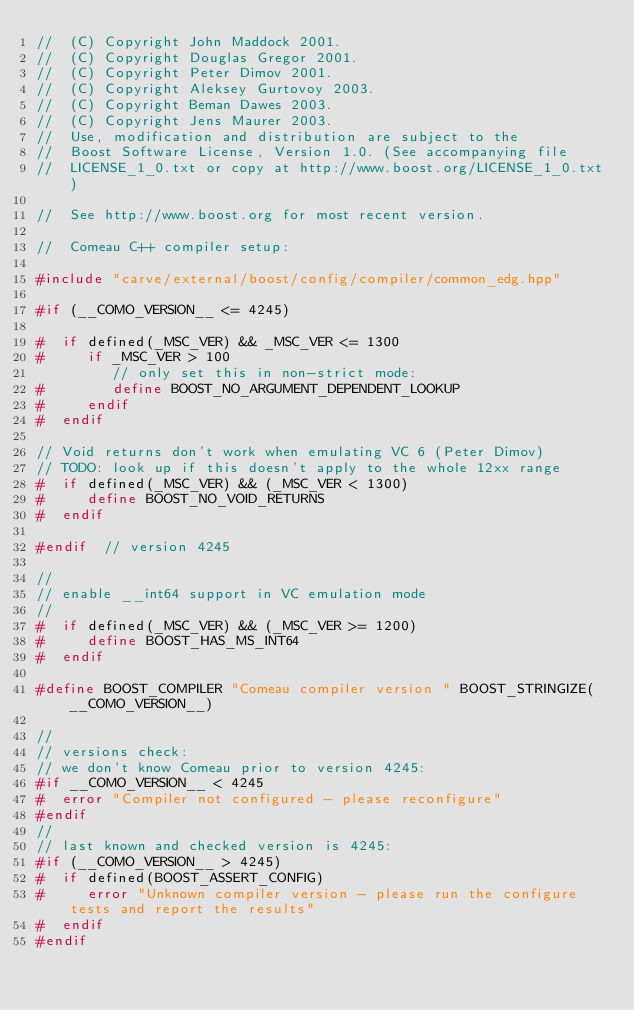<code> <loc_0><loc_0><loc_500><loc_500><_C++_>//  (C) Copyright John Maddock 2001. 
//  (C) Copyright Douglas Gregor 2001. 
//  (C) Copyright Peter Dimov 2001. 
//  (C) Copyright Aleksey Gurtovoy 2003. 
//  (C) Copyright Beman Dawes 2003. 
//  (C) Copyright Jens Maurer 2003. 
//  Use, modification and distribution are subject to the 
//  Boost Software License, Version 1.0. (See accompanying file 
//  LICENSE_1_0.txt or copy at http://www.boost.org/LICENSE_1_0.txt)

//  See http://www.boost.org for most recent version.

//  Comeau C++ compiler setup:

#include "carve/external/boost/config/compiler/common_edg.hpp"

#if (__COMO_VERSION__ <= 4245)

#  if defined(_MSC_VER) && _MSC_VER <= 1300
#     if _MSC_VER > 100
         // only set this in non-strict mode:
#        define BOOST_NO_ARGUMENT_DEPENDENT_LOOKUP
#     endif
#  endif

// Void returns don't work when emulating VC 6 (Peter Dimov)
// TODO: look up if this doesn't apply to the whole 12xx range
#  if defined(_MSC_VER) && (_MSC_VER < 1300)
#     define BOOST_NO_VOID_RETURNS
#  endif

#endif  // version 4245

//
// enable __int64 support in VC emulation mode
//
#  if defined(_MSC_VER) && (_MSC_VER >= 1200)
#     define BOOST_HAS_MS_INT64
#  endif

#define BOOST_COMPILER "Comeau compiler version " BOOST_STRINGIZE(__COMO_VERSION__)

//
// versions check:
// we don't know Comeau prior to version 4245:
#if __COMO_VERSION__ < 4245
#  error "Compiler not configured - please reconfigure"
#endif
//
// last known and checked version is 4245:
#if (__COMO_VERSION__ > 4245)
#  if defined(BOOST_ASSERT_CONFIG)
#     error "Unknown compiler version - please run the configure tests and report the results"
#  endif
#endif




</code> 